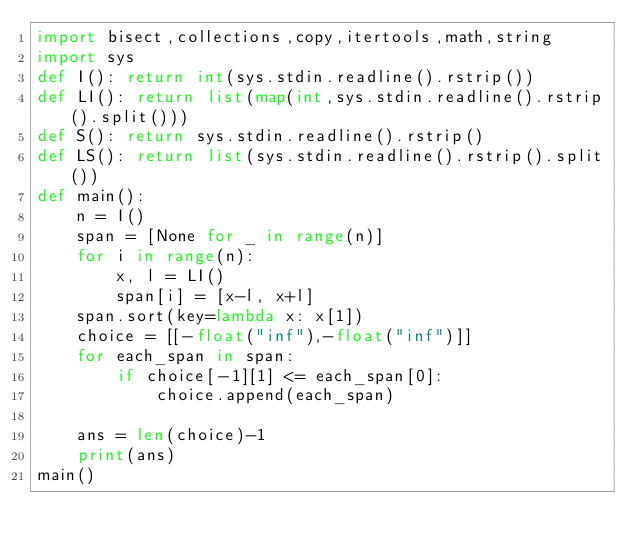<code> <loc_0><loc_0><loc_500><loc_500><_Python_>import bisect,collections,copy,itertools,math,string
import sys
def I(): return int(sys.stdin.readline().rstrip())
def LI(): return list(map(int,sys.stdin.readline().rstrip().split()))
def S(): return sys.stdin.readline().rstrip()
def LS(): return list(sys.stdin.readline().rstrip().split())
def main():
    n = I()
    span = [None for _ in range(n)]
    for i in range(n):
        x, l = LI()
        span[i] = [x-l, x+l]
    span.sort(key=lambda x: x[1])
    choice = [[-float("inf"),-float("inf")]]
    for each_span in span:
        if choice[-1][1] <= each_span[0]:
            choice.append(each_span)
    
    ans = len(choice)-1
    print(ans)
main()
</code> 